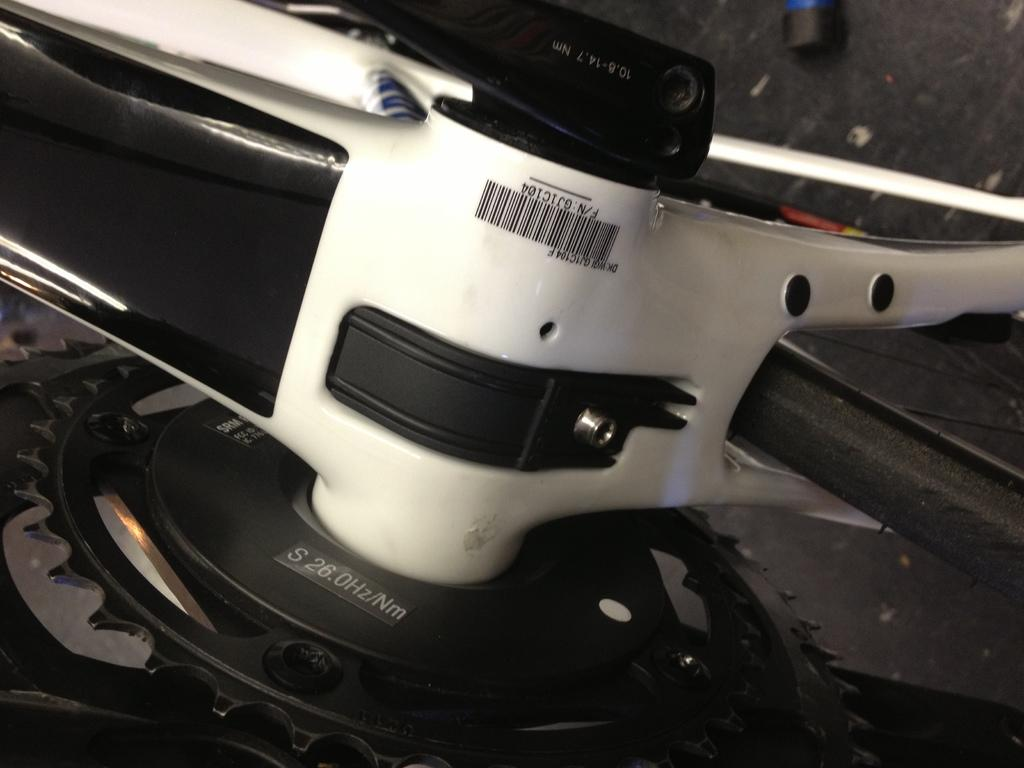What object related to a bicycle can be seen in the image? There is a spare part of a bicycle in the image. How many geese are flying over the spare part of the bicycle in the image? There are no geese present in the image; it only features a spare part of a bicycle. Does the spare part of the bicycle sneeze in the image? The spare part of the bicycle does not have the ability to sneeze, as it is an inanimate object. 